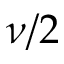Convert formula to latex. <formula><loc_0><loc_0><loc_500><loc_500>\nu / 2</formula> 